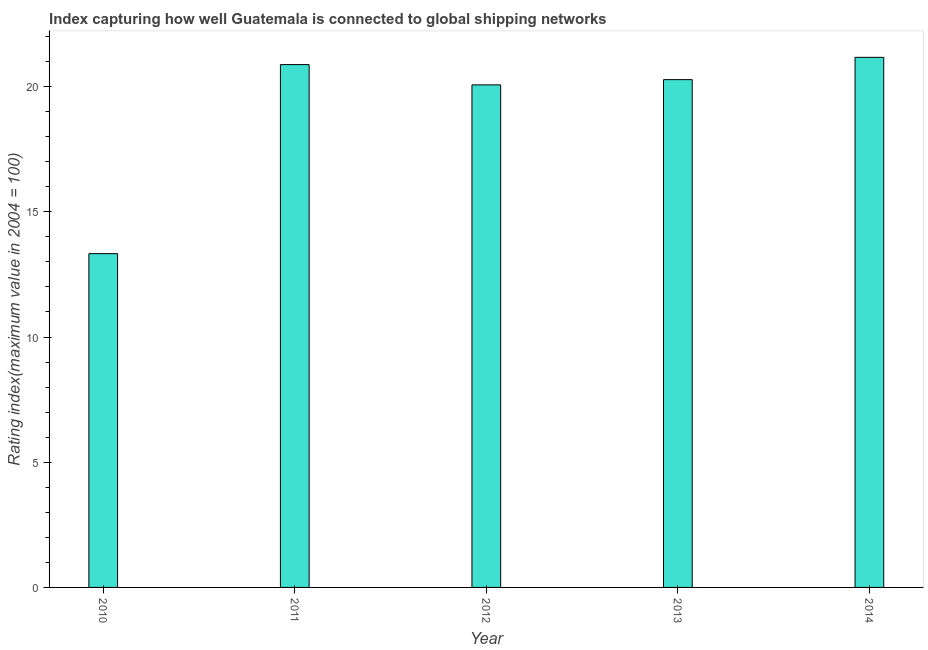Does the graph contain any zero values?
Your answer should be compact. No. What is the title of the graph?
Provide a succinct answer. Index capturing how well Guatemala is connected to global shipping networks. What is the label or title of the Y-axis?
Your answer should be compact. Rating index(maximum value in 2004 = 100). What is the liner shipping connectivity index in 2011?
Ensure brevity in your answer.  20.88. Across all years, what is the maximum liner shipping connectivity index?
Offer a very short reply. 21.17. Across all years, what is the minimum liner shipping connectivity index?
Provide a short and direct response. 13.33. What is the sum of the liner shipping connectivity index?
Offer a terse response. 95.73. What is the difference between the liner shipping connectivity index in 2010 and 2013?
Offer a terse response. -6.95. What is the average liner shipping connectivity index per year?
Provide a short and direct response. 19.15. What is the median liner shipping connectivity index?
Your answer should be compact. 20.28. Do a majority of the years between 2010 and 2013 (inclusive) have liner shipping connectivity index greater than 10 ?
Ensure brevity in your answer.  Yes. What is the ratio of the liner shipping connectivity index in 2010 to that in 2011?
Offer a terse response. 0.64. What is the difference between the highest and the second highest liner shipping connectivity index?
Offer a very short reply. 0.29. What is the difference between the highest and the lowest liner shipping connectivity index?
Provide a short and direct response. 7.84. How many bars are there?
Give a very brief answer. 5. Are all the bars in the graph horizontal?
Your answer should be very brief. No. Are the values on the major ticks of Y-axis written in scientific E-notation?
Ensure brevity in your answer.  No. What is the Rating index(maximum value in 2004 = 100) of 2010?
Provide a short and direct response. 13.33. What is the Rating index(maximum value in 2004 = 100) of 2011?
Give a very brief answer. 20.88. What is the Rating index(maximum value in 2004 = 100) of 2012?
Make the answer very short. 20.07. What is the Rating index(maximum value in 2004 = 100) of 2013?
Provide a short and direct response. 20.28. What is the Rating index(maximum value in 2004 = 100) of 2014?
Your answer should be compact. 21.17. What is the difference between the Rating index(maximum value in 2004 = 100) in 2010 and 2011?
Give a very brief answer. -7.55. What is the difference between the Rating index(maximum value in 2004 = 100) in 2010 and 2012?
Your answer should be compact. -6.74. What is the difference between the Rating index(maximum value in 2004 = 100) in 2010 and 2013?
Offer a terse response. -6.95. What is the difference between the Rating index(maximum value in 2004 = 100) in 2010 and 2014?
Your answer should be compact. -7.84. What is the difference between the Rating index(maximum value in 2004 = 100) in 2011 and 2012?
Offer a terse response. 0.81. What is the difference between the Rating index(maximum value in 2004 = 100) in 2011 and 2013?
Make the answer very short. 0.6. What is the difference between the Rating index(maximum value in 2004 = 100) in 2011 and 2014?
Provide a succinct answer. -0.29. What is the difference between the Rating index(maximum value in 2004 = 100) in 2012 and 2013?
Keep it short and to the point. -0.21. What is the difference between the Rating index(maximum value in 2004 = 100) in 2012 and 2014?
Your answer should be very brief. -1.1. What is the difference between the Rating index(maximum value in 2004 = 100) in 2013 and 2014?
Your answer should be very brief. -0.89. What is the ratio of the Rating index(maximum value in 2004 = 100) in 2010 to that in 2011?
Provide a short and direct response. 0.64. What is the ratio of the Rating index(maximum value in 2004 = 100) in 2010 to that in 2012?
Ensure brevity in your answer.  0.66. What is the ratio of the Rating index(maximum value in 2004 = 100) in 2010 to that in 2013?
Offer a terse response. 0.66. What is the ratio of the Rating index(maximum value in 2004 = 100) in 2010 to that in 2014?
Make the answer very short. 0.63. What is the ratio of the Rating index(maximum value in 2004 = 100) in 2011 to that in 2012?
Your answer should be compact. 1.04. What is the ratio of the Rating index(maximum value in 2004 = 100) in 2011 to that in 2013?
Provide a short and direct response. 1.03. What is the ratio of the Rating index(maximum value in 2004 = 100) in 2011 to that in 2014?
Provide a succinct answer. 0.99. What is the ratio of the Rating index(maximum value in 2004 = 100) in 2012 to that in 2013?
Ensure brevity in your answer.  0.99. What is the ratio of the Rating index(maximum value in 2004 = 100) in 2012 to that in 2014?
Offer a very short reply. 0.95. What is the ratio of the Rating index(maximum value in 2004 = 100) in 2013 to that in 2014?
Make the answer very short. 0.96. 